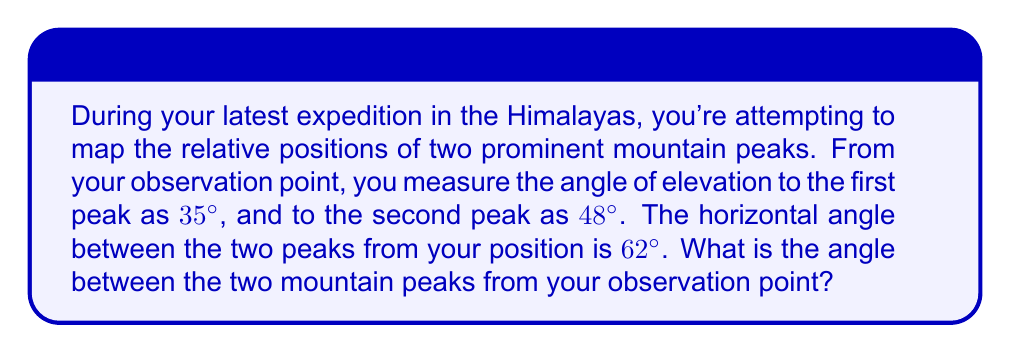Show me your answer to this math problem. To solve this problem, we need to use spherical trigonometry. The situation can be modeled as a spherical triangle, where:

1. The observer is at the center of the sphere
2. The two mountain peaks and the observer form a spherical triangle on the surface of this imaginary sphere

Let's approach this step-by-step:

1) First, we need to convert the given angles to their complements, as spherical trigonometry uses the angles from zenith (directly overhead) rather than from the horizon:

   $a = 90° - 35° = 55°$
   $b = 90° - 48° = 42°$
   $C = 62°$ (the horizontal angle remains the same)

2) Now, we can use the spherical law of cosines to find the angle $A$ between the two mountain peaks:

   $$\cos(c) = \cos(a)\cos(b) + \sin(a)\sin(b)\cos(C)$$

   Where $c$ is the angle we're looking for, and $a$, $b$, and $C$ are the angles we calculated in step 1.

3) Let's substitute our values:

   $$\cos(c) = \cos(55°)\cos(42°) + \sin(55°)\sin(42°)\cos(62°)$$

4) Now we calculate:

   $$\cos(c) = (0.5736)(0.7431) + (0.8192)(0.6691)(0.4695)$$
   $$\cos(c) = 0.4262 + 0.2571$$
   $$\cos(c) = 0.6833$$

5) To find $c$, we take the inverse cosine (arccos) of both sides:

   $$c = \arccos(0.6833)$$
   $$c \approx 46.9°$$

Therefore, the angle between the two mountain peaks from your observation point is approximately 46.9°.
Answer: $46.9°$ 